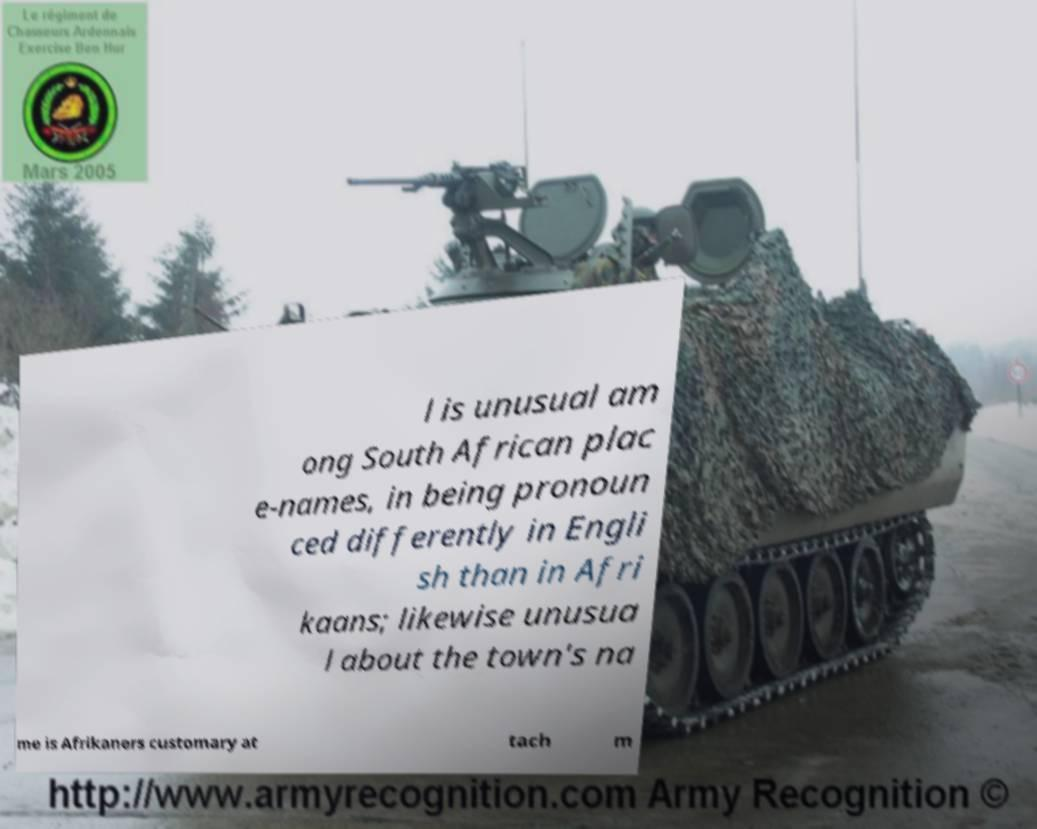Can you accurately transcribe the text from the provided image for me? l is unusual am ong South African plac e-names, in being pronoun ced differently in Engli sh than in Afri kaans; likewise unusua l about the town's na me is Afrikaners customary at tach m 